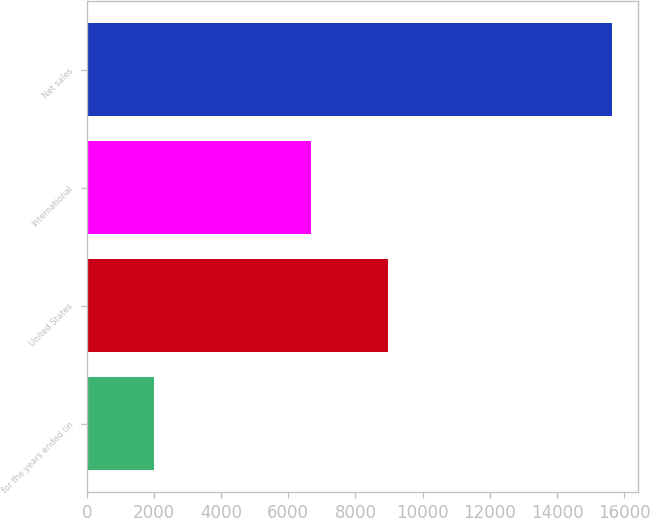Convert chart. <chart><loc_0><loc_0><loc_500><loc_500><bar_chart><fcel>for the years ended (in<fcel>United States<fcel>International<fcel>Net sales<nl><fcel>2010<fcel>8971<fcel>6667<fcel>15638<nl></chart> 